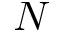<formula> <loc_0><loc_0><loc_500><loc_500>N</formula> 